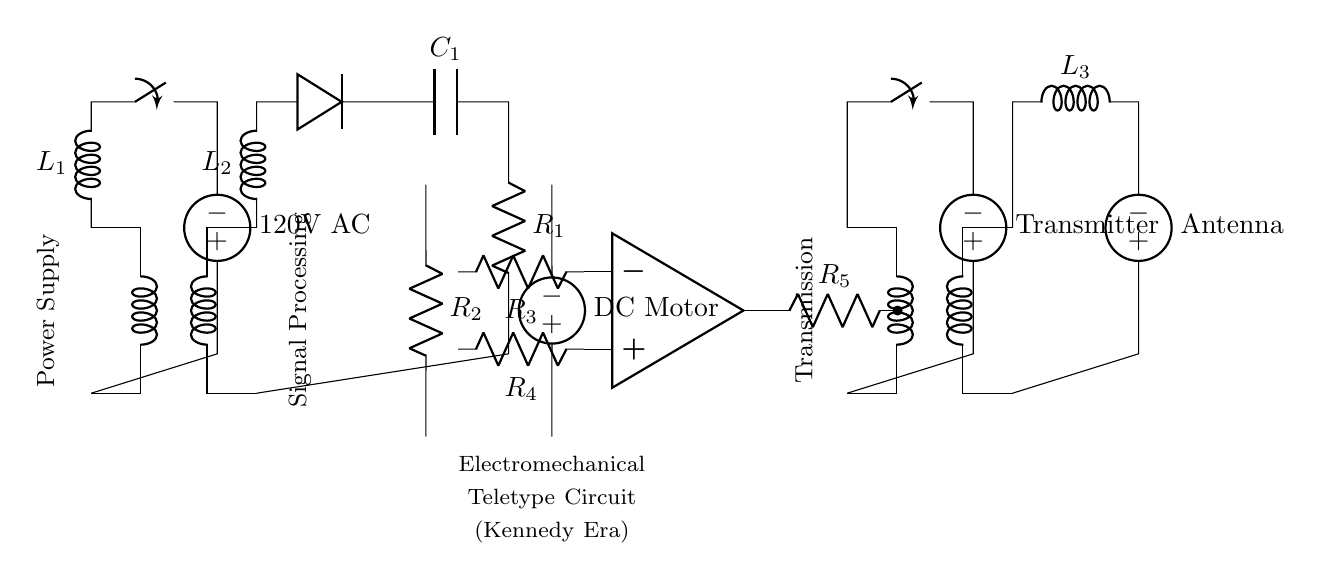What type of circuit is this? This circuit is an electromechanical teletype circuit, designed to transmit news reports. It includes components that handle AC and DC voltages.
Answer: Electromechanical teletype What is the main voltage source used in the circuit? The main voltage source used in the circuit is a 120V AC. This is indicated next to the transformer labeled T1.
Answer: 120V AC What component is used for signal processing in this circuit? The op-amp component, labeled as OP1, is responsible for signal processing. It is connected with resistors for input and output signal control.
Answer: Op-amp How many inductors are present in this circuit? There are three inductors in this circuit, labeled L1, L2, and L3, as depicted in the various branches.
Answer: Three What is the purpose of the diode in the circuit? The diode is used to allow current to flow in one direction only, providing rectification of the AC signal before it reaches the capacitor.
Answer: Rectification How is the information transmitted in this circuit? Information is transmitted using a transmitter connected to the antenna, which is powered by the circuit's voltage source. The transmission occurs through high-frequency oscillations generated by the processed signals.
Answer: Transmitter and antenna What is the role of the DC motor in the circuit? The DC motor is responsible for the mechanical action in the teletype system, likely operated based on the signals processed prior to the motor component.
Answer: Mechanical action 